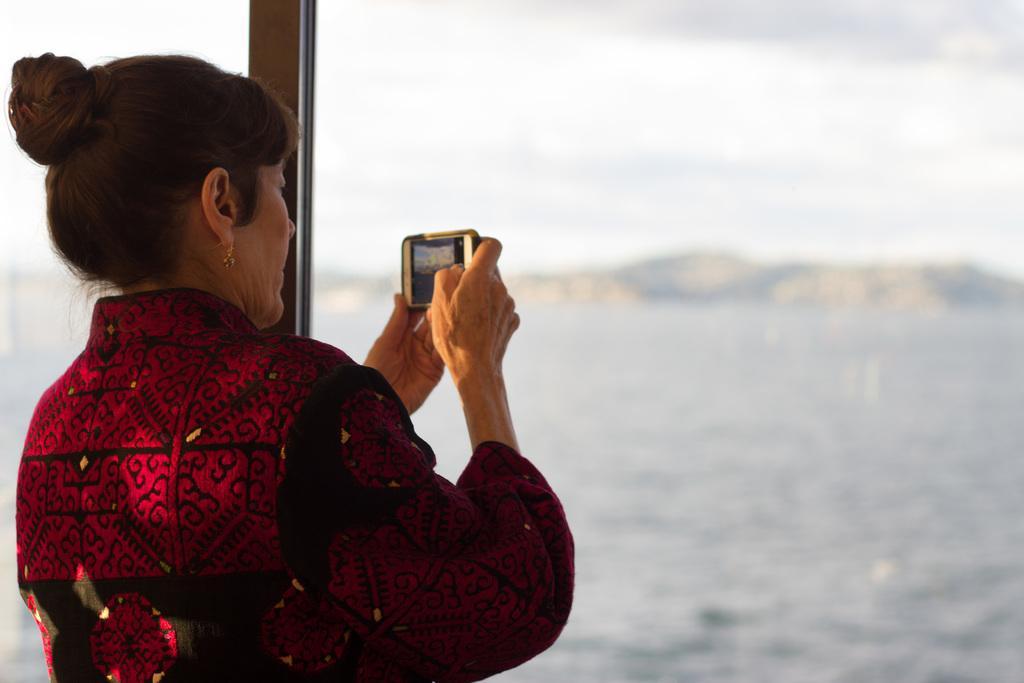How would you summarize this image in a sentence or two? This picture describes about a woman she is holding a mobile in her hand and we can see some water. 